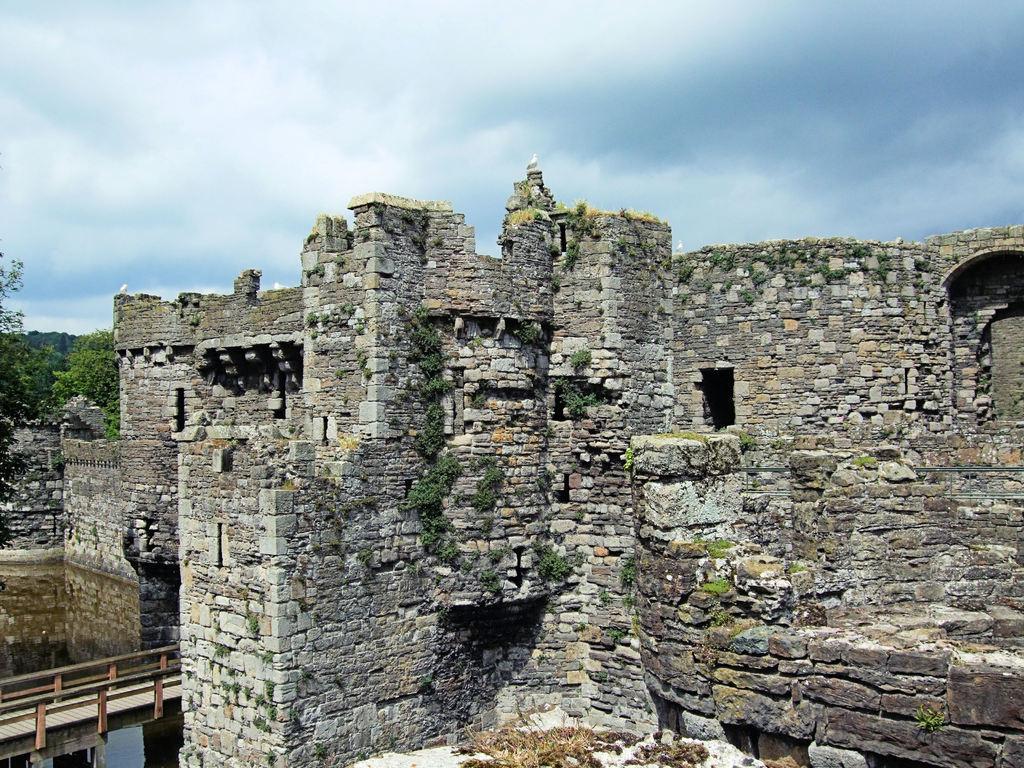Can you describe this image briefly? In this image I can see the fort. To the side I can see the railing and the water. In the background there are many trees, clouds and the sky. 